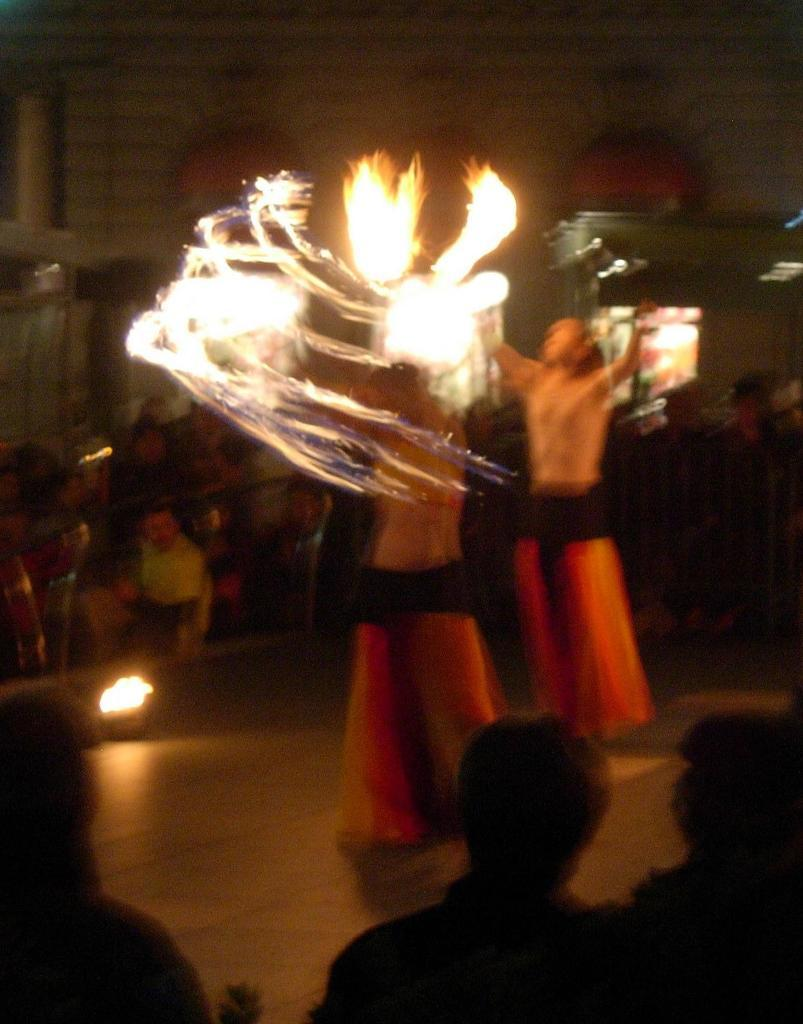What is the main subject of the image? The main subject of the image is a group of people. Can you identify any specific individuals in the image? Yes, there are two specific people in the image. What is happening in front of the group of people? There is a fire in front in the image. How would you describe the quality of the image? The image is blurred. What type of stick is being used to serve the pies in the image? There is no mention of pies or sticks being used to serve them in the image. Is there a doctor present in the image? There is no mention of a doctor or any medical professionals in the image. 